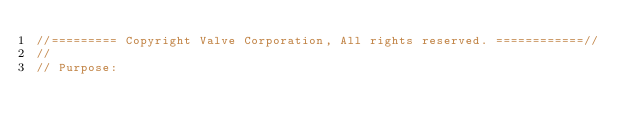<code> <loc_0><loc_0><loc_500><loc_500><_C++_>//========= Copyright Valve Corporation, All rights reserved. ============//
//
// Purpose: </code> 